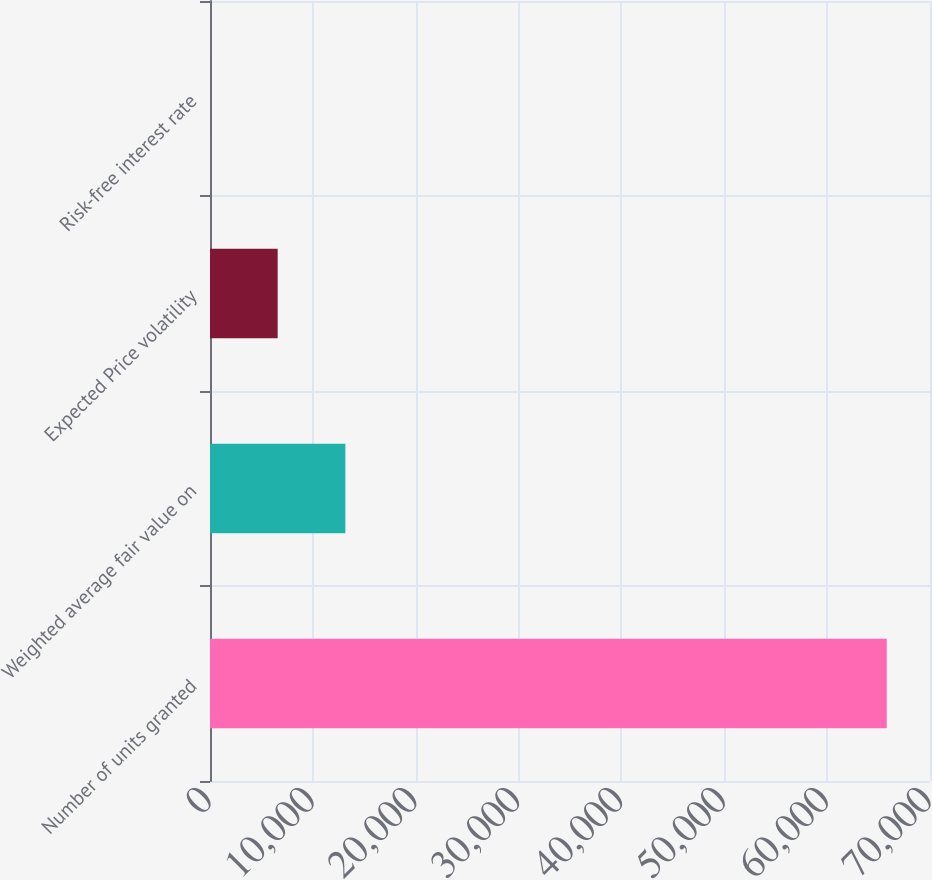Convert chart to OTSL. <chart><loc_0><loc_0><loc_500><loc_500><bar_chart><fcel>Number of units granted<fcel>Weighted average fair value on<fcel>Expected Price volatility<fcel>Risk-free interest rate<nl><fcel>65796<fcel>13160<fcel>6580.55<fcel>1.05<nl></chart> 